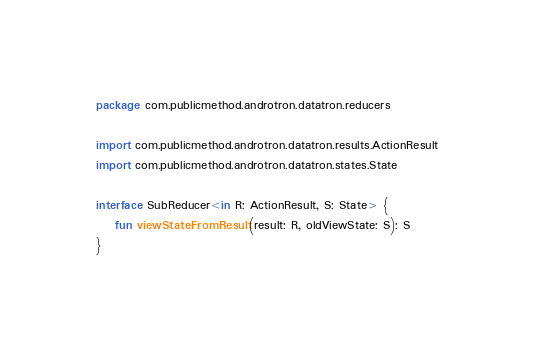<code> <loc_0><loc_0><loc_500><loc_500><_Kotlin_>package com.publicmethod.androtron.datatron.reducers

import com.publicmethod.androtron.datatron.results.ActionResult
import com.publicmethod.androtron.datatron.states.State

interface SubReducer<in R: ActionResult, S: State> {
    fun viewStateFromResult(result: R, oldViewState: S): S
}</code> 